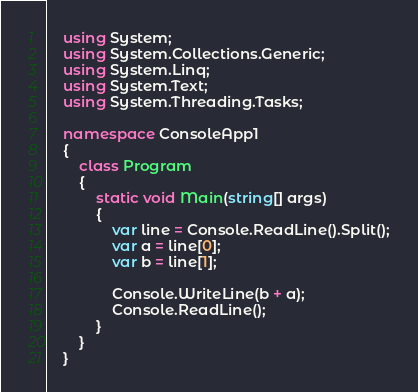Convert code to text. <code><loc_0><loc_0><loc_500><loc_500><_C#_>    using System;
    using System.Collections.Generic;
    using System.Linq;
    using System.Text;
    using System.Threading.Tasks;
     
    namespace ConsoleApp1
    {
        class Program
        {
            static void Main(string[] args)
            {
                var line = Console.ReadLine().Split();
                var a = line[0];
                var b = line[1];
     
                Console.WriteLine(b + a);
                Console.ReadLine();
            }
        }
    }</code> 